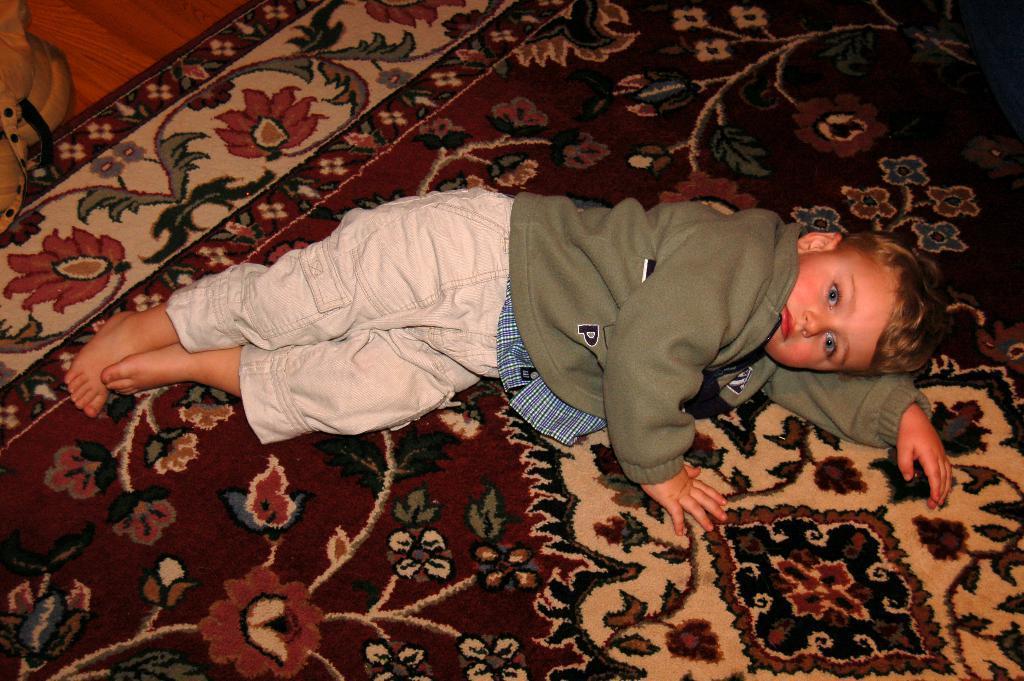In one or two sentences, can you explain what this image depicts? In the image there is a boy lying on the floor mat. In the top left corner of the image there is an object. 